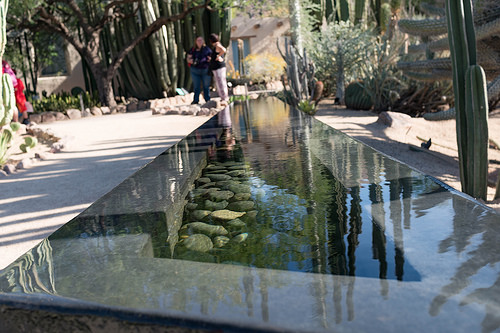<image>
Can you confirm if the pants is on the girl? No. The pants is not positioned on the girl. They may be near each other, but the pants is not supported by or resting on top of the girl. 